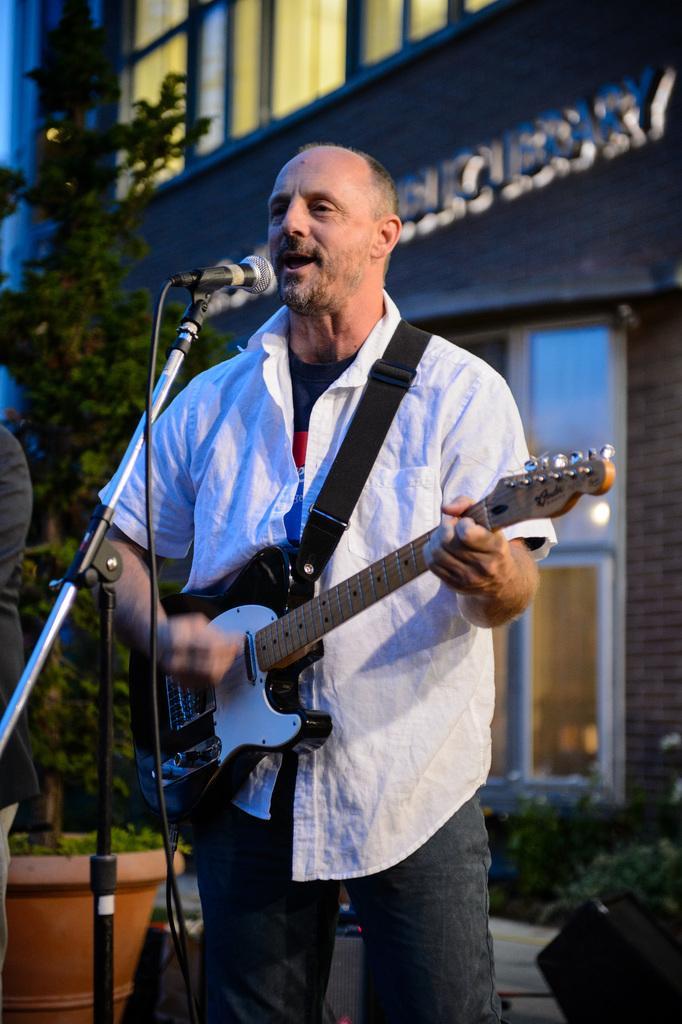How would you summarize this image in a sentence or two? In this image there is a man standing and playing a guitar by singing a song in the microphone and in back ground there is tree, building , plant. 